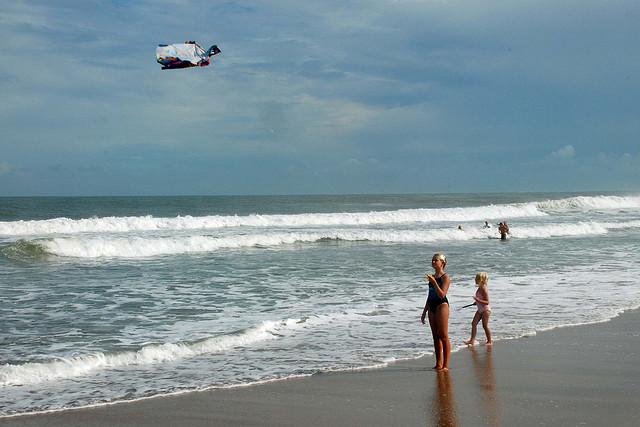What is the gender of the people closest to the camera?
Short answer required. Female. Are these two people prepared to swim?
Quick response, please. Yes. What color is the sand?
Short answer required. Brown. 